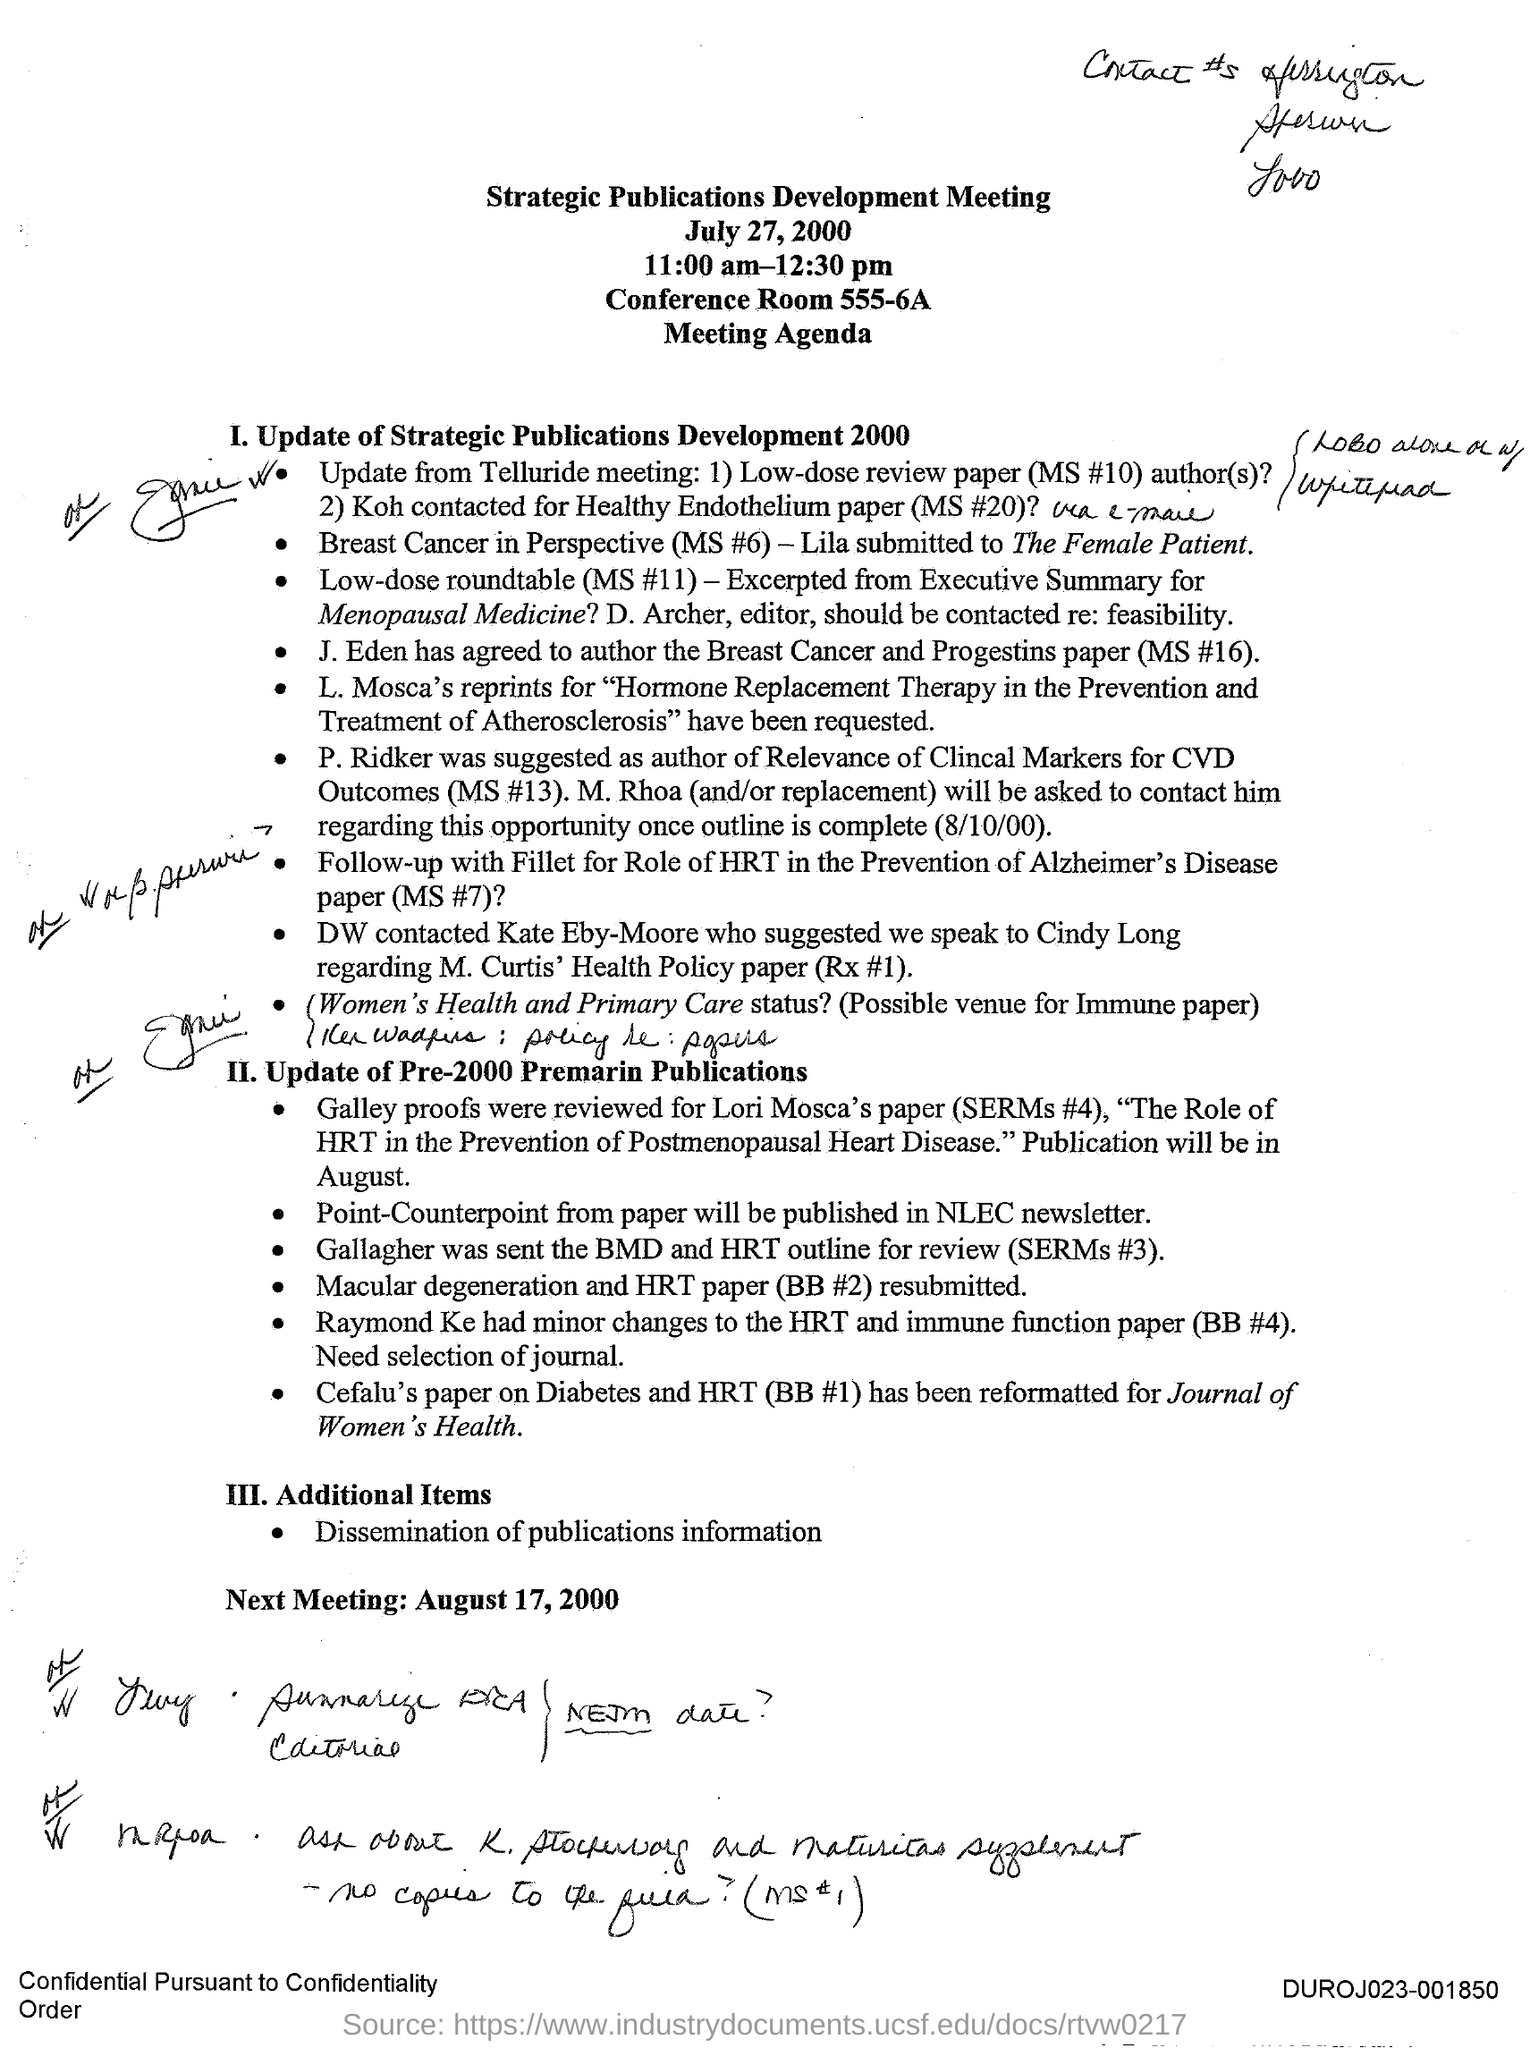What is the title?
Keep it short and to the point. Strategic Publication Development Meeting. When is the strategic publications development meeting?
Your response must be concise. July 27, 2000. What was the meeting timings?
Make the answer very short. 11:00 AM-12:30 PM. Where was the meeting held?
Provide a succinct answer. Conference room 555-6A. What is the second main agenda?
Offer a very short reply. Update of pre-2000 premarin publications. When was the next meeting?
Provide a succinct answer. August 17, 2000. 